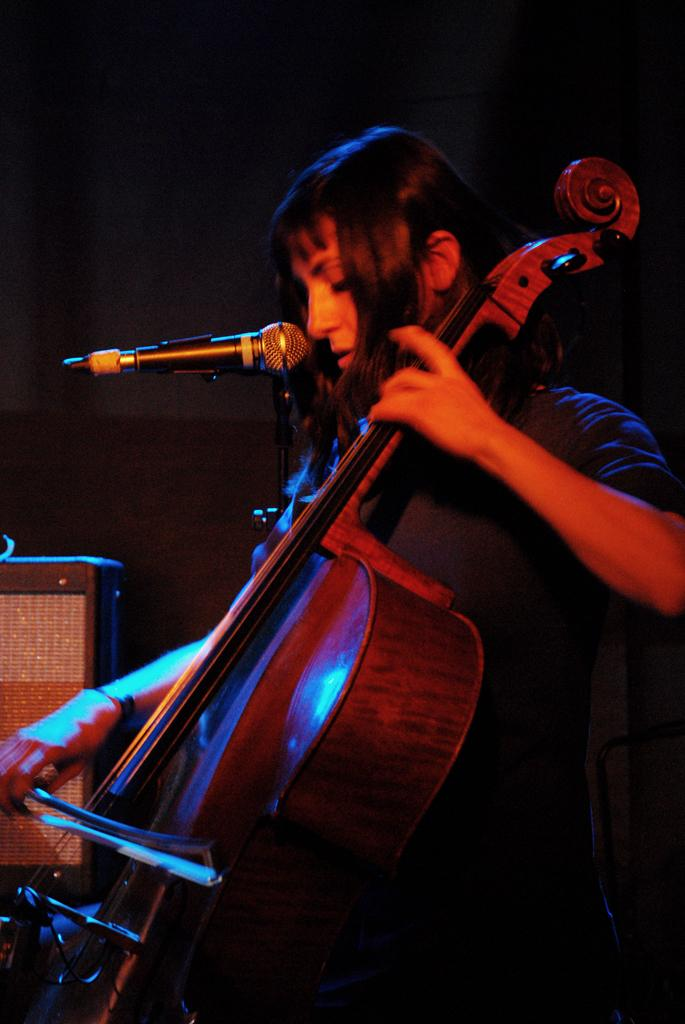What is the main subject of the image? There is a person in the image. What is the person doing in the image? The person is standing, playing the violin, and singing with a microphone. What color is the rose on the side of the person's skin in the image? There is no rose present in the image, and the person's skin color is not mentioned in the provided facts. 